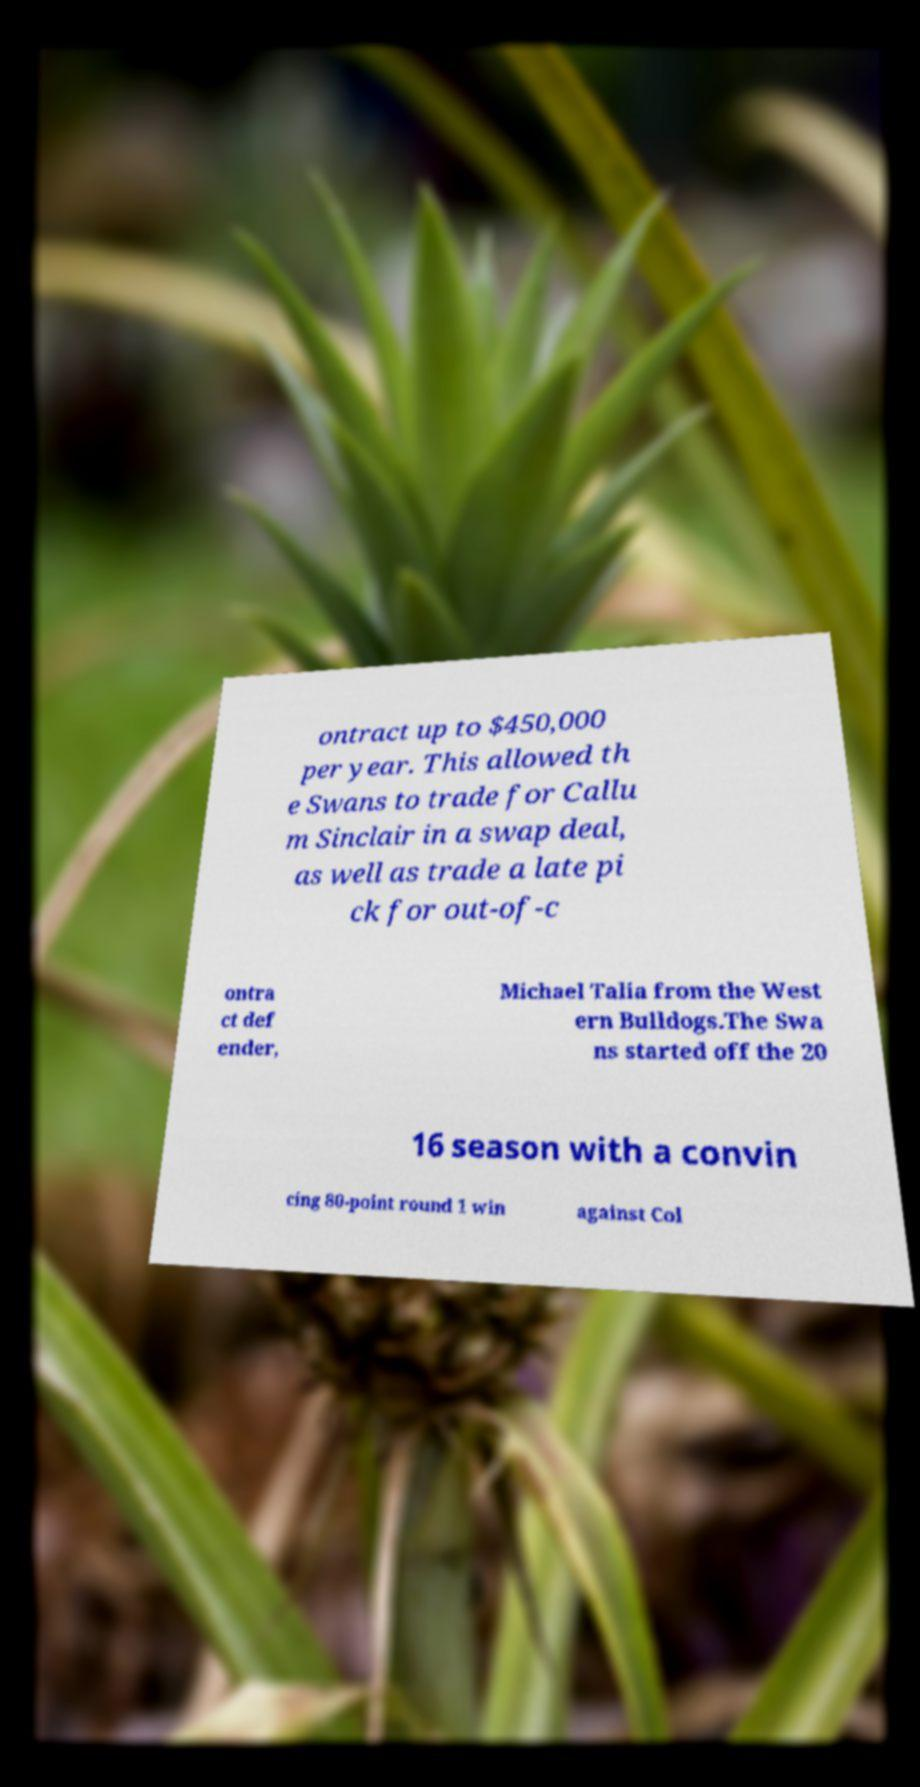Please identify and transcribe the text found in this image. ontract up to $450,000 per year. This allowed th e Swans to trade for Callu m Sinclair in a swap deal, as well as trade a late pi ck for out-of-c ontra ct def ender, Michael Talia from the West ern Bulldogs.The Swa ns started off the 20 16 season with a convin cing 80-point round 1 win against Col 